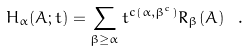Convert formula to latex. <formula><loc_0><loc_0><loc_500><loc_500>H _ { \alpha } ( A ; t ) = \sum _ { \beta \geq \alpha } t ^ { c ( \alpha , \beta ^ { c } ) } R _ { \beta } ( A ) \ .</formula> 